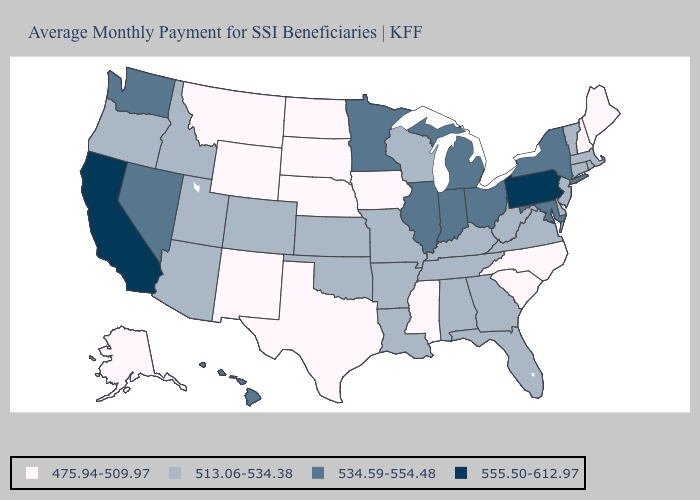What is the value of Colorado?
Write a very short answer. 513.06-534.38. Name the states that have a value in the range 475.94-509.97?
Give a very brief answer. Alaska, Iowa, Maine, Mississippi, Montana, Nebraska, New Hampshire, New Mexico, North Carolina, North Dakota, South Carolina, South Dakota, Texas, Wyoming. What is the value of Utah?
Quick response, please. 513.06-534.38. Does California have the highest value in the West?
Be succinct. Yes. Which states have the lowest value in the West?
Keep it brief. Alaska, Montana, New Mexico, Wyoming. Name the states that have a value in the range 534.59-554.48?
Keep it brief. Hawaii, Illinois, Indiana, Maryland, Michigan, Minnesota, Nevada, New York, Ohio, Washington. Name the states that have a value in the range 555.50-612.97?
Concise answer only. California, Pennsylvania. Name the states that have a value in the range 555.50-612.97?
Short answer required. California, Pennsylvania. Does Iowa have the lowest value in the USA?
Quick response, please. Yes. What is the value of Georgia?
Keep it brief. 513.06-534.38. Name the states that have a value in the range 534.59-554.48?
Concise answer only. Hawaii, Illinois, Indiana, Maryland, Michigan, Minnesota, Nevada, New York, Ohio, Washington. Among the states that border Rhode Island , which have the highest value?
Be succinct. Connecticut, Massachusetts. Which states have the lowest value in the USA?
Give a very brief answer. Alaska, Iowa, Maine, Mississippi, Montana, Nebraska, New Hampshire, New Mexico, North Carolina, North Dakota, South Carolina, South Dakota, Texas, Wyoming. Does Tennessee have the lowest value in the South?
Concise answer only. No. Is the legend a continuous bar?
Short answer required. No. 